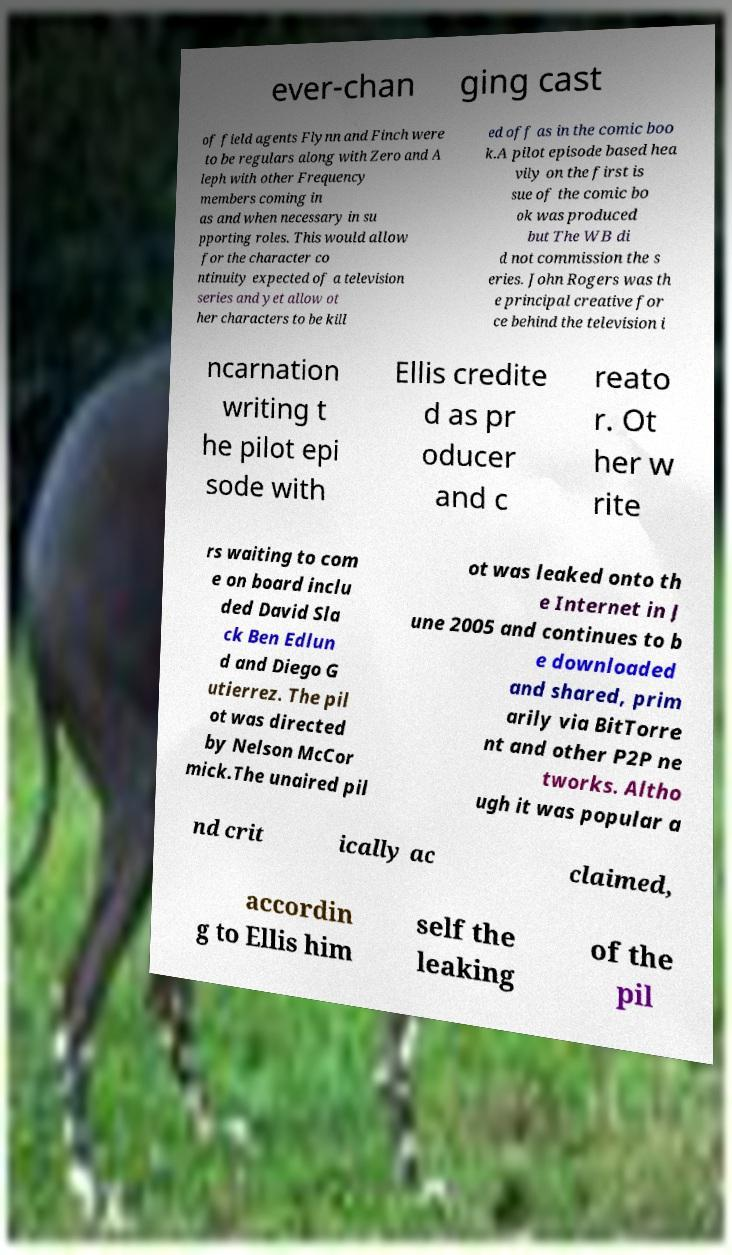Please read and relay the text visible in this image. What does it say? ever-chan ging cast of field agents Flynn and Finch were to be regulars along with Zero and A leph with other Frequency members coming in as and when necessary in su pporting roles. This would allow for the character co ntinuity expected of a television series and yet allow ot her characters to be kill ed off as in the comic boo k.A pilot episode based hea vily on the first is sue of the comic bo ok was produced but The WB di d not commission the s eries. John Rogers was th e principal creative for ce behind the television i ncarnation writing t he pilot epi sode with Ellis credite d as pr oducer and c reato r. Ot her w rite rs waiting to com e on board inclu ded David Sla ck Ben Edlun d and Diego G utierrez. The pil ot was directed by Nelson McCor mick.The unaired pil ot was leaked onto th e Internet in J une 2005 and continues to b e downloaded and shared, prim arily via BitTorre nt and other P2P ne tworks. Altho ugh it was popular a nd crit ically ac claimed, accordin g to Ellis him self the leaking of the pil 